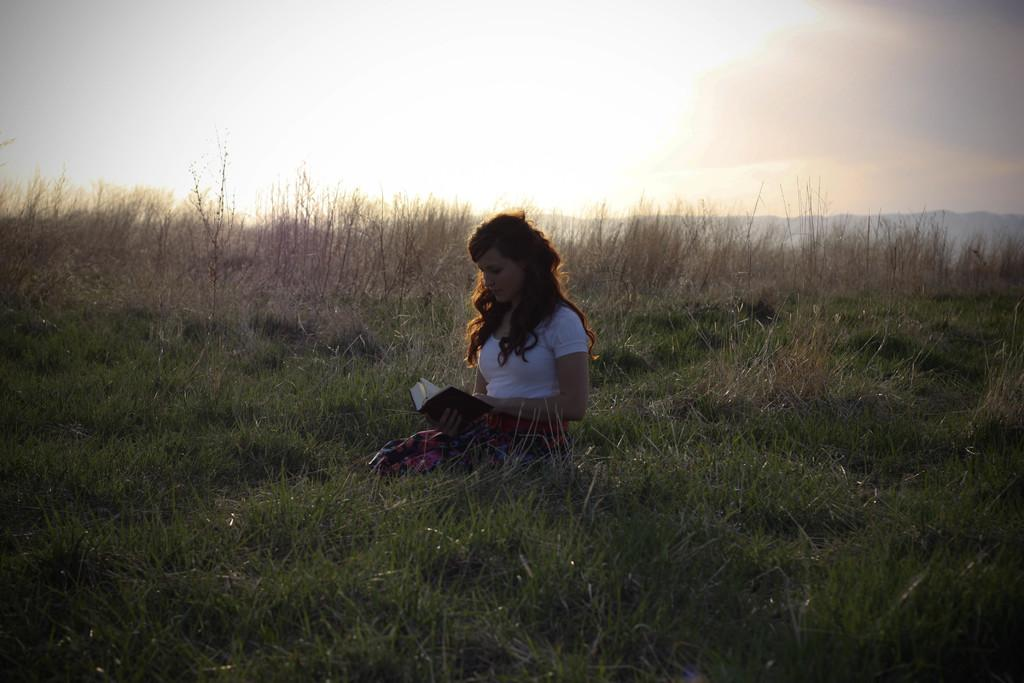Who is in the image? There is a girl in the image. What is the girl doing in the image? The girl is sitting on the grass in the image. What object does the girl have with her? The girl has a book with her in the image. What type of natural environment is visible in the image? There is grass and hills visible in the background of the image. What is visible in the sky in the image? The sky is visible in the background of the image. What type of pollution can be seen in the image? There is no pollution visible in the image; it features a girl sitting on the grass with a book. What type of coil is the girl using to read the book in the image? There is no coil present in the image; the girl is simply holding a book while sitting on the grass. 